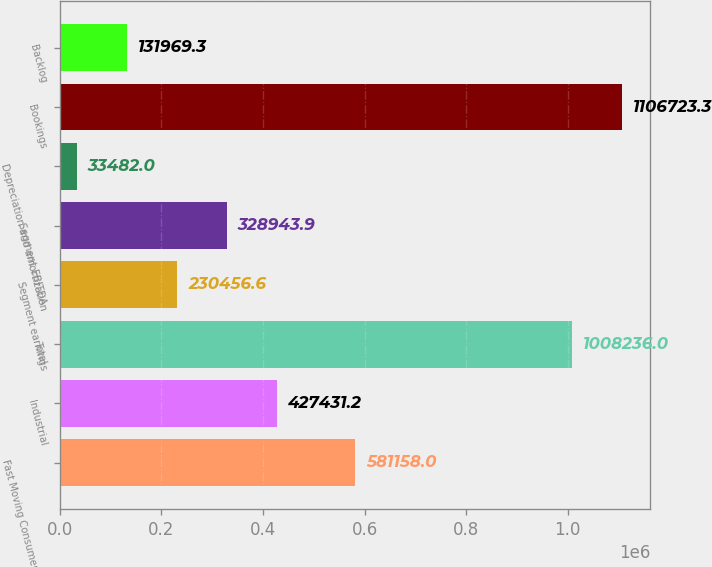<chart> <loc_0><loc_0><loc_500><loc_500><bar_chart><fcel>Fast Moving Consumer Goods<fcel>Industrial<fcel>Total<fcel>Segment earnings<fcel>Segment EBITDA<fcel>Depreciation and amortization<fcel>Bookings<fcel>Backlog<nl><fcel>581158<fcel>427431<fcel>1.00824e+06<fcel>230457<fcel>328944<fcel>33482<fcel>1.10672e+06<fcel>131969<nl></chart> 